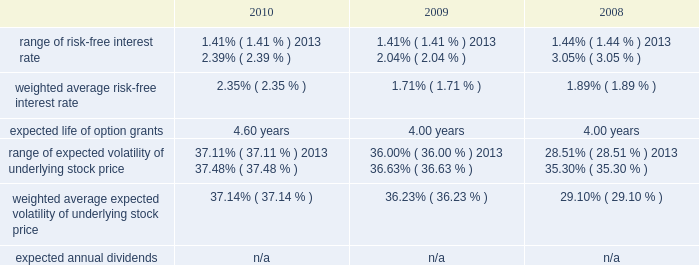American tower corporation and subsidiaries notes to consolidated financial statements assessments in each of the tax jurisdictions resulting from these examinations .
The company believes that adequate provisions have been made for income taxes for all periods through december 31 , 2010 .
12 .
Stock-based compensation the company recognized stock-based compensation of $ 52.6 million , $ 60.7 million and $ 54.8 million for the years ended december 31 , 2010 , 2009 and 2008 , respectively .
Stock-based compensation for the year ended december 31 , 2009 included $ 6.9 million related to the modification of the vesting and exercise terms for certain employee 2019s equity awards .
The company did not capitalize any stock-based compensation during the years ended december 31 , 2010 and 2009 .
Summary of stock-based compensation plans 2014the company maintains equity incentive plans that provide for the grant of stock-based awards to its directors , officers and employees .
Under the 2007 equity incentive plan ( 201c2007 plan 201d ) , which provides for the grant of non-qualified and incentive stock options , as well as restricted stock units , restricted stock and other stock-based awards , exercise prices in the case of non-qualified and incentive stock options are not less than the fair market value of the underlying common stock on the date of grant .
Equity awards typically vest ratably over various periods , generally four years , and generally expire ten years from the date of grant .
Stock options 2014as of december 31 , 2010 , the company had the ability to grant stock-based awards with respect to an aggregate of 22.0 million shares of common stock under the 2007 plan .
The fair value of each option grant is estimated on the date of grant using the black-scholes option pricing model based on the assumptions noted in the table below .
The risk-free treasury rate is based on the u.s .
Treasury yield in effect at the accounting measurement date .
The expected life ( estimated period of time outstanding ) was estimated using the vesting term and historical exercise behavior of company employees .
The expected volatility was based on historical volatility for a period equal to the expected life of the stock options .
Key assumptions used to apply this pricing model are as follows: .
The weighted average grant date fair value per share during the years ended december 31 , 2010 , 2009 and 2008 was $ 15.03 , $ 8.90 and $ 9.55 , respectively .
The intrinsic value of stock options exercised during the years ended december 31 , 2010 , 2009 and 2008 was $ 62.7 million , $ 40.1 million and $ 99.1 million , respectively .
As of december 31 , 2010 , total unrecognized compensation expense related to unvested stock options was approximately $ 27.7 million and is expected to be recognized over a weighted average period of approximately two years .
The amount of cash received from the exercise of stock options was approximately $ 129.1 million during the year ended december 31 , 2010 .
During the year ended december 31 , 2010 , the company realized approximately $ 0.3 million of state tax benefits from the exercise of stock options. .
What was the percent of the change in the intrinsic value of stock options from 2009 to 2010? 
Computations: ((62.7 - 40.1) / 40.1)
Answer: 0.56359. 